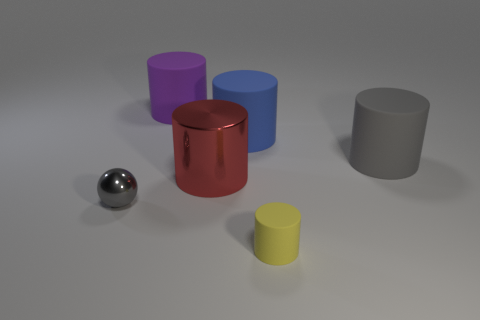The red thing is what size?
Offer a terse response. Large. What is the material of the big red thing?
Your response must be concise. Metal. There is a gray thing behind the red object; is its size the same as the blue matte object?
Ensure brevity in your answer.  Yes. How many objects are either big things or small red rubber objects?
Your answer should be compact. 4. The large thing that is the same color as the ball is what shape?
Keep it short and to the point. Cylinder. There is a object that is both left of the big shiny object and to the right of the tiny gray sphere; what size is it?
Provide a short and direct response. Large. What number of tiny metal things are there?
Your answer should be compact. 1. What number of cylinders are either small matte objects or large gray things?
Provide a short and direct response. 2. What number of gray things are to the right of the metal thing that is to the right of the shiny object that is on the left side of the shiny cylinder?
Your response must be concise. 1. The rubber thing that is the same size as the ball is what color?
Offer a terse response. Yellow. 